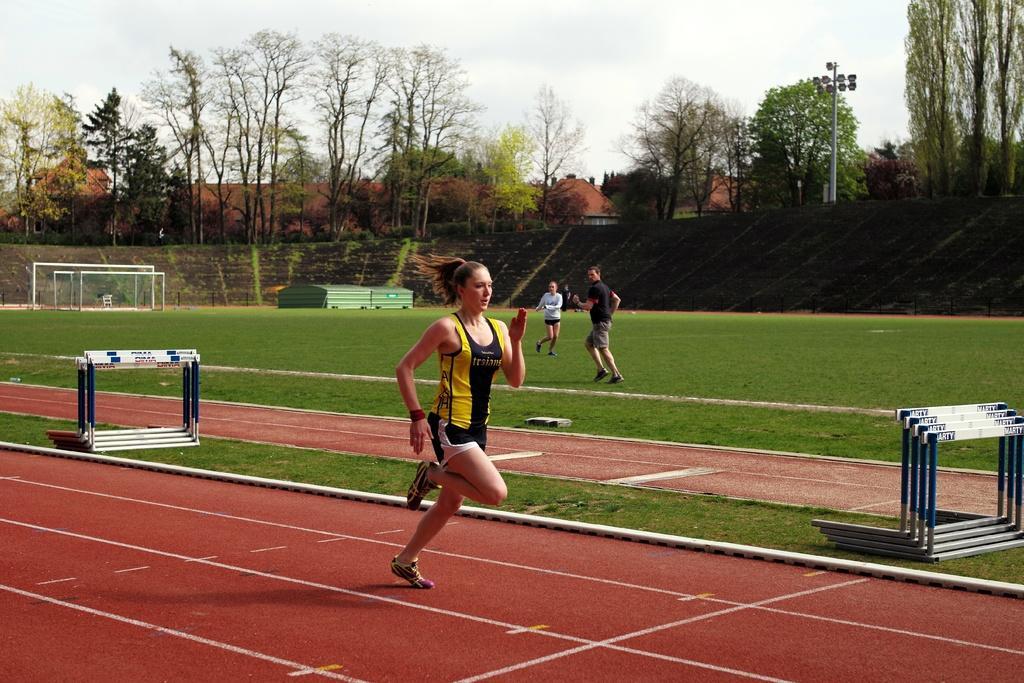How would you summarize this image in a sentence or two? Here we can see a woman running on the ground. This is grass and there are few people. Here we can see a mesh, pole, and screens. 